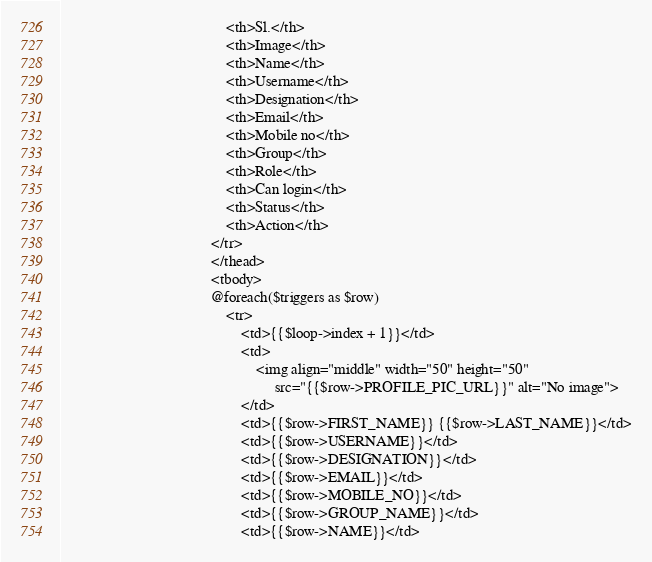<code> <loc_0><loc_0><loc_500><loc_500><_PHP_>                                            <th>Sl.</th>
                                            <th>Image</th>
                                            <th>Name</th>
                                            <th>Username</th>
                                            <th>Designation</th>
                                            <th>Email</th>
                                            <th>Mobile no</th>
                                            <th>Group</th>
                                            <th>Role</th>
                                            <th>Can login</th>
                                            <th>Status</th>
                                            <th>Action</th>
                                        </tr>
                                        </thead>
                                        <tbody>
                                        @foreach($triggers as $row)
                                            <tr>
                                                <td>{{$loop->index + 1}}</td>
                                                <td>
                                                    <img align="middle" width="50" height="50"
                                                         src="{{$row->PROFILE_PIC_URL}}" alt="No image">
                                                </td>
                                                <td>{{$row->FIRST_NAME}} {{$row->LAST_NAME}}</td>
                                                <td>{{$row->USERNAME}}</td>
                                                <td>{{$row->DESIGNATION}}</td>
                                                <td>{{$row->EMAIL}}</td>
                                                <td>{{$row->MOBILE_NO}}</td>
                                                <td>{{$row->GROUP_NAME}}</td>
                                                <td>{{$row->NAME}}</td></code> 